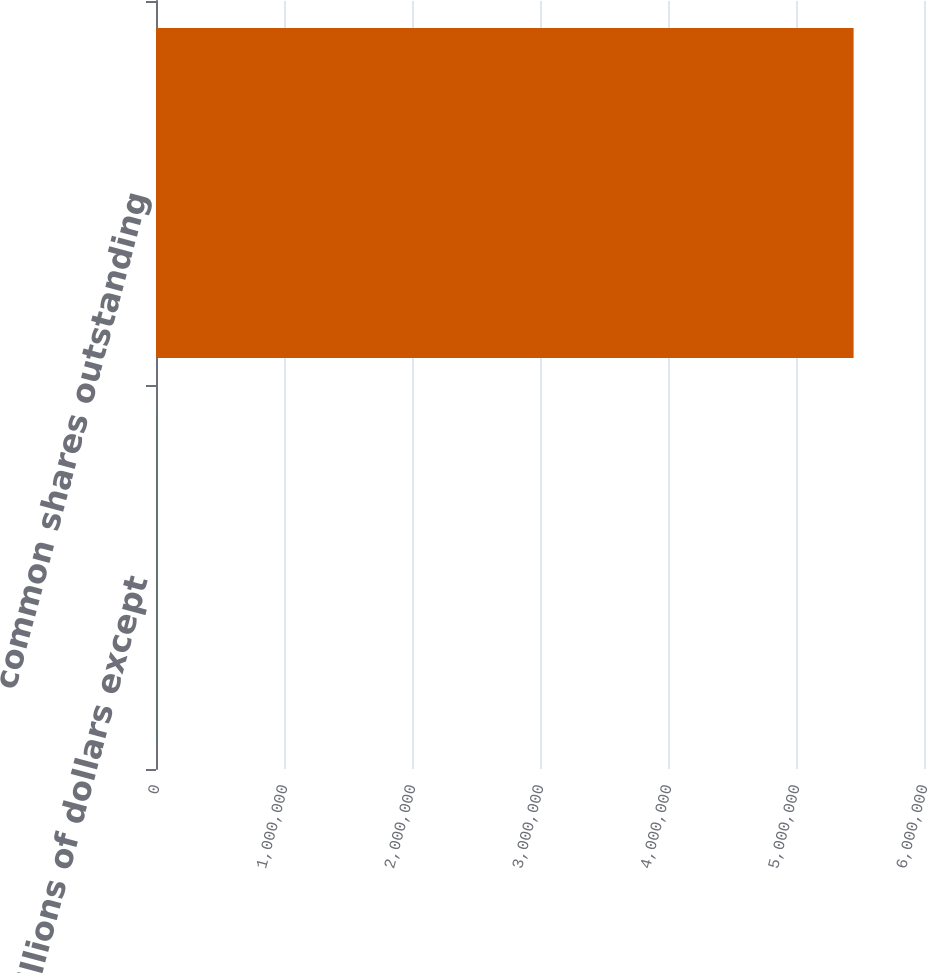Convert chart to OTSL. <chart><loc_0><loc_0><loc_500><loc_500><bar_chart><fcel>In millions of dollars except<fcel>common shares outstanding<nl><fcel>2008<fcel>5.45007e+06<nl></chart> 